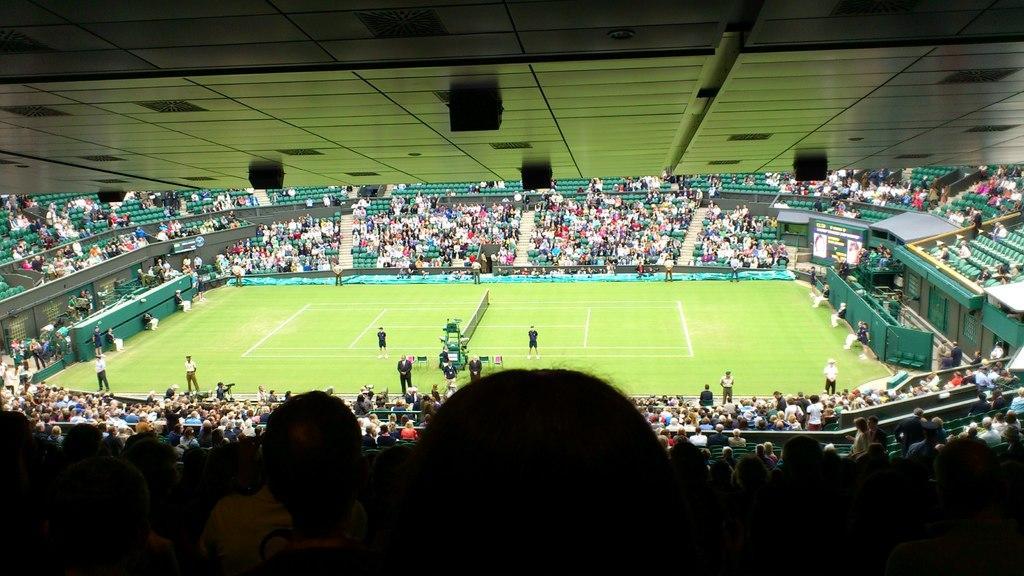How would you summarize this image in a sentence or two? This image is clicked at a stadium. In the center of the image there is a ground. There is grass on the ground. There are a few people standing on the ground. Around the ground there are many people sitting on the chairs. At the top there is the ceiling. 